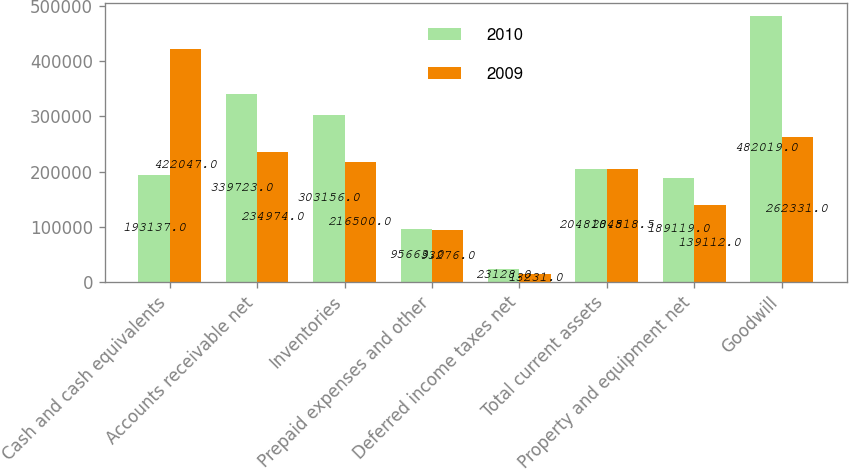Convert chart. <chart><loc_0><loc_0><loc_500><loc_500><stacked_bar_chart><ecel><fcel>Cash and cash equivalents<fcel>Accounts receivable net<fcel>Inventories<fcel>Prepaid expenses and other<fcel>Deferred income taxes net<fcel>Total current assets<fcel>Property and equipment net<fcel>Goodwill<nl><fcel>2010<fcel>193137<fcel>339723<fcel>303156<fcel>95663<fcel>23128<fcel>204818<fcel>189119<fcel>482019<nl><fcel>2009<fcel>422047<fcel>234974<fcel>216500<fcel>93276<fcel>13231<fcel>204818<fcel>139112<fcel>262331<nl></chart> 